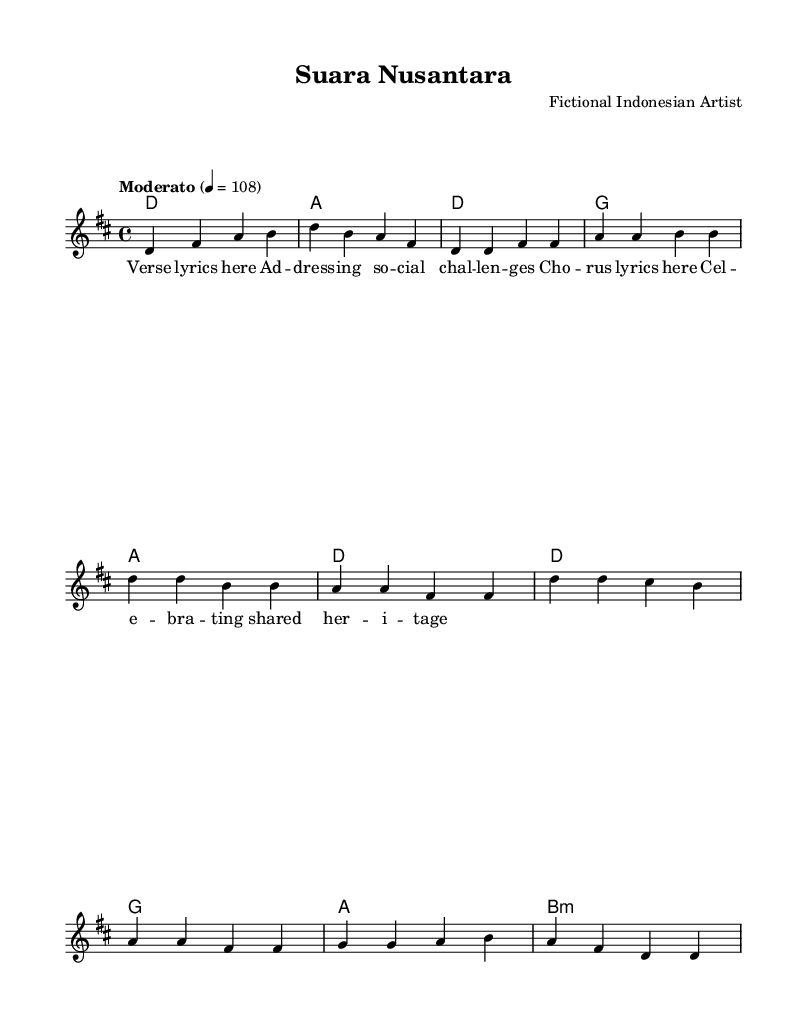What is the key signature of this music? The key signature is D major, which has two sharps: F# and C#.
Answer: D major What is the time signature of this music? The time signature is 4/4, which indicates four beats per measure.
Answer: 4/4 What is the tempo indicated in the music? The tempo is marked as "Moderato" with a metronomic setting of 108.
Answer: Moderato 4 = 108 How many measures are in the Chorus section? The Chorus section consists of four measures, indicating the parts of the song that repeat themes and ideas.
Answer: 4 What type of musical progression is used in the Verse? The musical progression in the Verse is D - G - A - D, which establishes a common tonal structure in contemporary songs.
Answer: D - G - A - D What is the vocal range indicated in the melody? The melodic line indicates a vocal range starting from D in the octave above middle C, suggesting a soprano range typically found in pop music performances.
Answer: Soprano Which social issues does the song address based on its themes mentioned in the lyrics? The lyrics refer to social challenges and the celebration of heritage, hinting at social identity and cultural discussions relevant in contemporary Indonesia.
Answer: Social challenges 